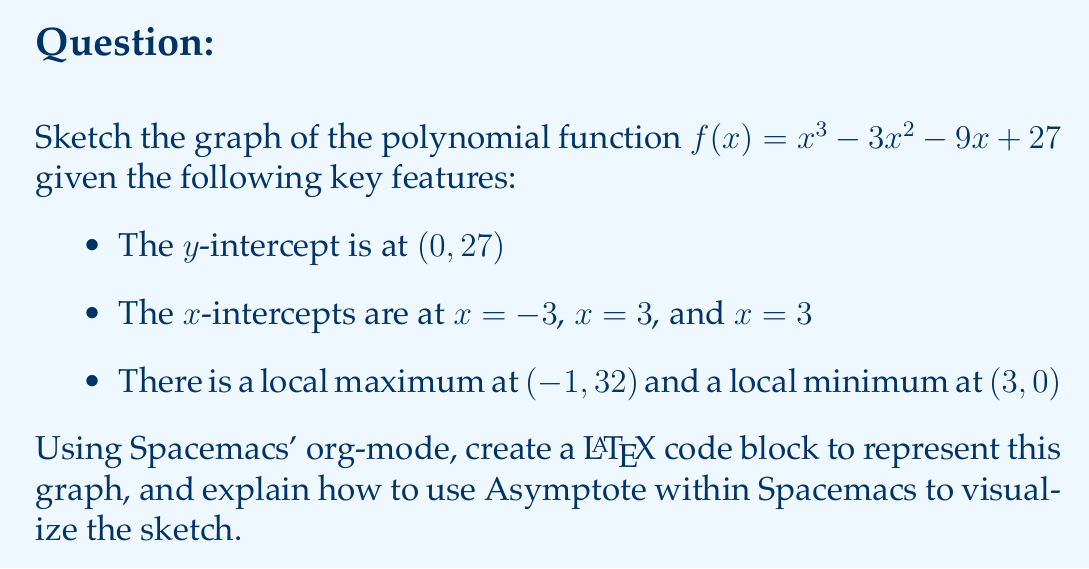Teach me how to tackle this problem. To sketch the graph of the polynomial function $f(x) = x^3 - 3x^2 - 9x + 27$, we'll follow these steps:

1. Identify the degree of the polynomial:
   The polynomial is of degree 3, so it will have at most 3 x-intercepts and 2 turning points.

2. Plot the given key features:
   - y-intercept: (0, 27)
   - x-intercepts: (-3, 0), (3, 0), (3, 0)
   - Local maximum: (-1, 32)
   - Local minimum: (3, 0)

3. Determine the end behavior:
   As a cubic function with a positive leading coefficient, the graph will approach positive infinity as x approaches positive infinity, and negative infinity as x approaches negative infinity.

4. Connect the points to form a smooth curve that passes through all the given points and follows the end behavior.

To create a LaTeX code block in Spacemacs' org-mode to represent this graph:

1. Open a new org-mode file in Spacemacs.
2. Insert a LaTeX code block by typing `#+BEGIN_SRC latex` and `#+END_SRC` on separate lines.
3. Between these lines, insert the following LaTeX code:

```latex
\begin{tikzpicture}
\begin{axis}[
    axis lines = middle,
    xlabel = $x$,
    ylabel = $y$,
    xmin = -4, xmax = 4,
    ymin = -5, ymax = 35,
    xtick = {-3,-1,3},
    ytick = {27,32},
    legend pos = north west,
    ymajorgrids = true,
    grid style = dashed,
]
\addplot[
    domain = -4:4,
    samples = 100,
    smooth,
    thick,
    blue,
] {x^3 - 3*x^2 - 9*x + 27};
\addlegendentry{$f(x) = x^3 - 3x^2 - 9x + 27$}

\addplot[mark=*] coordinates {(0,27) (-3,0) (3,0) (-1,32) (3,0)};

\end{axis}
\end{tikzpicture}
```

To use Asymptote within Spacemacs for visualization:

1. Install the Asymptote package if not already installed.
2. Create an Asymptote code block by typing `#+BEGIN_SRC asymptote` and `#+END_SRC` on separate lines.
3. Between these lines, insert Asymptote code to draw the graph.
4. Use `C-c C-c` to compile and view the Asymptote output.

Example Asymptote code:

```asymptote
import graph;
size(200,200);

real f(real x) {return x^3 - 3*x^2 - 9*x + 27;}

draw(graph(f,-4,4), blue);
dot((0,27));
dot((-3,0));
dot((3,0));
dot((-1,32));
dot((3,0));

xaxis("$x$", Arrow);
yaxis("$y$", Arrow);
```

This process allows you to create and visualize the polynomial graph directly within Spacemacs.
Answer: Cubic curve passing through (-3,0), (0,27), (3,0) with local max at (-1,32) and local min at (3,0), approaching ∞ as x→∞ and -∞ as x→-∞. 